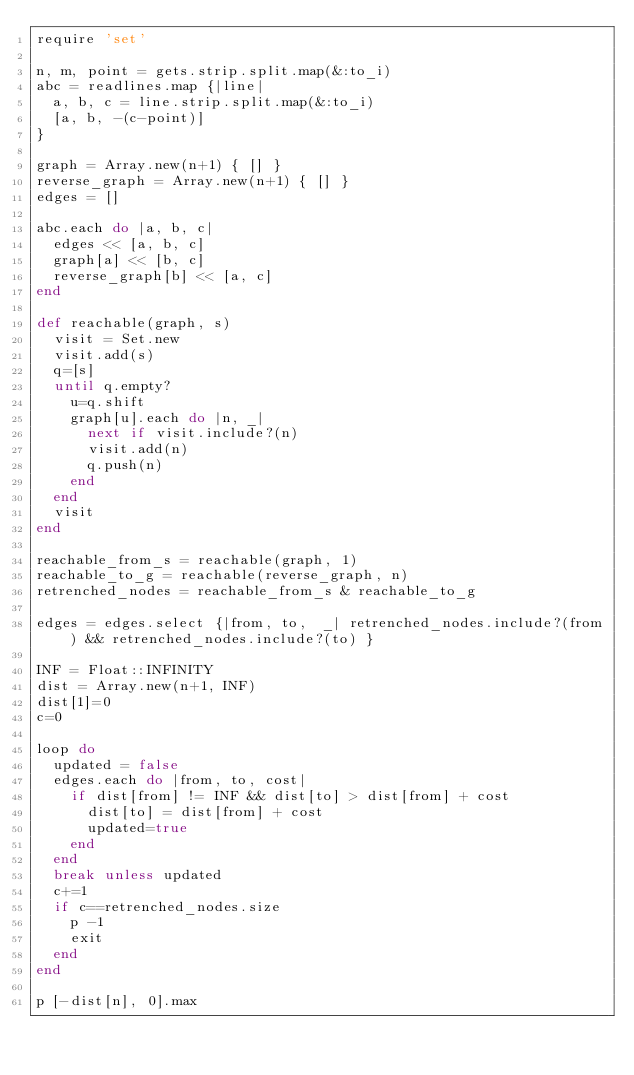Convert code to text. <code><loc_0><loc_0><loc_500><loc_500><_Ruby_>require 'set'

n, m, point = gets.strip.split.map(&:to_i)
abc = readlines.map {|line| 
  a, b, c = line.strip.split.map(&:to_i)
  [a, b, -(c-point)]
}

graph = Array.new(n+1) { [] }
reverse_graph = Array.new(n+1) { [] }
edges = []

abc.each do |a, b, c|
  edges << [a, b, c]
  graph[a] << [b, c]
  reverse_graph[b] << [a, c]
end

def reachable(graph, s)
  visit = Set.new
  visit.add(s)
  q=[s]
  until q.empty?
    u=q.shift
    graph[u].each do |n, _|
      next if visit.include?(n)
      visit.add(n)
      q.push(n)
    end
  end
  visit
end

reachable_from_s = reachable(graph, 1)
reachable_to_g = reachable(reverse_graph, n)
retrenched_nodes = reachable_from_s & reachable_to_g

edges = edges.select {|from, to,  _| retrenched_nodes.include?(from) && retrenched_nodes.include?(to) }

INF = Float::INFINITY
dist = Array.new(n+1, INF)
dist[1]=0
c=0

loop do
  updated = false
  edges.each do |from, to, cost|
    if dist[from] != INF && dist[to] > dist[from] + cost
      dist[to] = dist[from] + cost
      updated=true
    end
  end
  break unless updated
  c+=1
  if c==retrenched_nodes.size
    p -1
    exit
  end
end

p [-dist[n], 0].max
</code> 